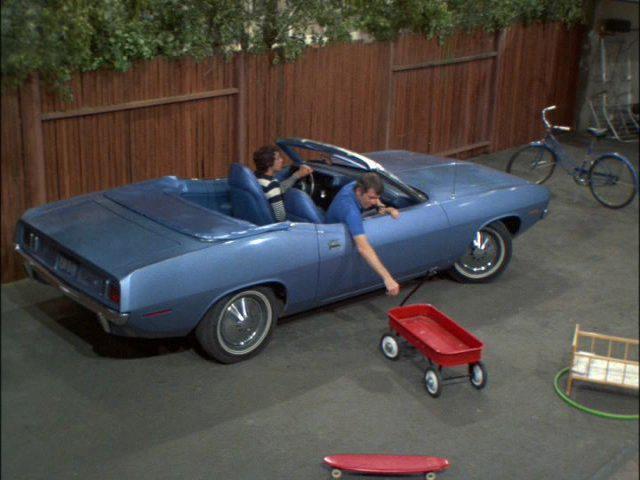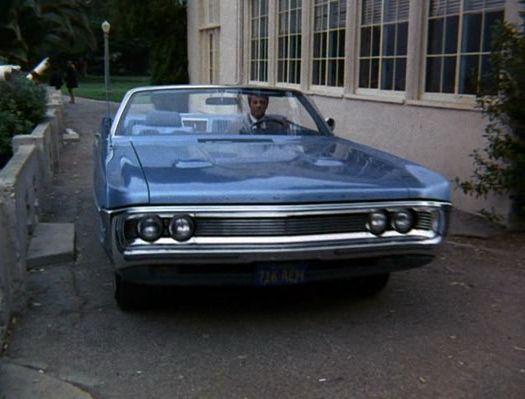The first image is the image on the left, the second image is the image on the right. Assess this claim about the two images: "There is more than one person in one of the cars.". Correct or not? Answer yes or no. Yes. The first image is the image on the left, the second image is the image on the right. Given the left and right images, does the statement "A man in a brown suit is standing." hold true? Answer yes or no. No. 